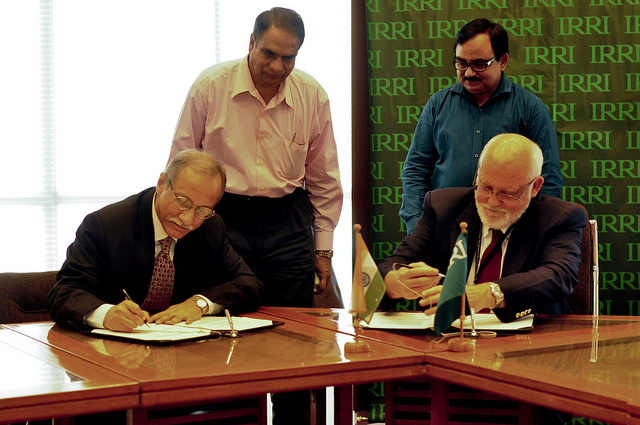What is the nature of the event taking place? The image suggests a formal event, possibly a contract signing or an agreement between two parties, as indicated by the men seated with pens ready to sign documents. 